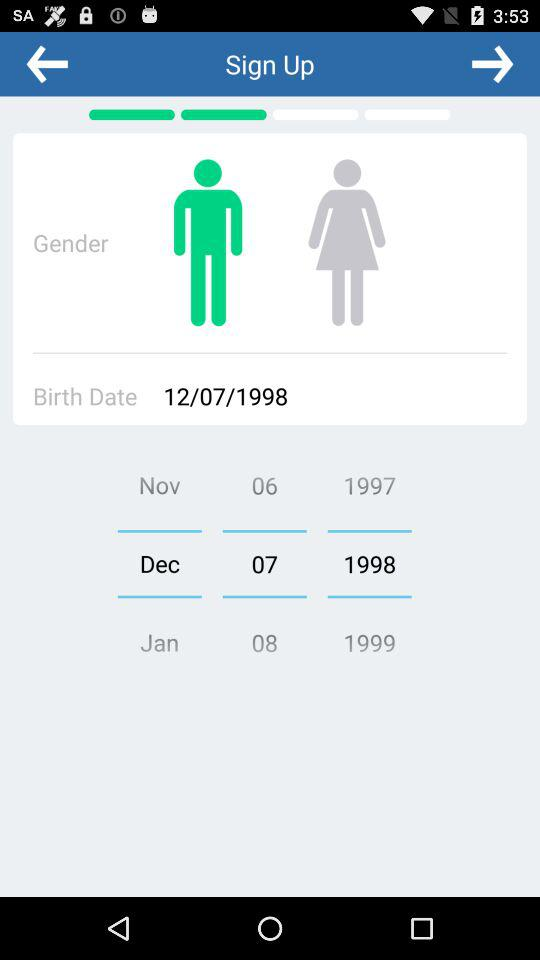What is the selected birthdate? The selected birthdate is 12/07/1998. 